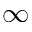Convert formula to latex. <formula><loc_0><loc_0><loc_500><loc_500>\infty</formula> 